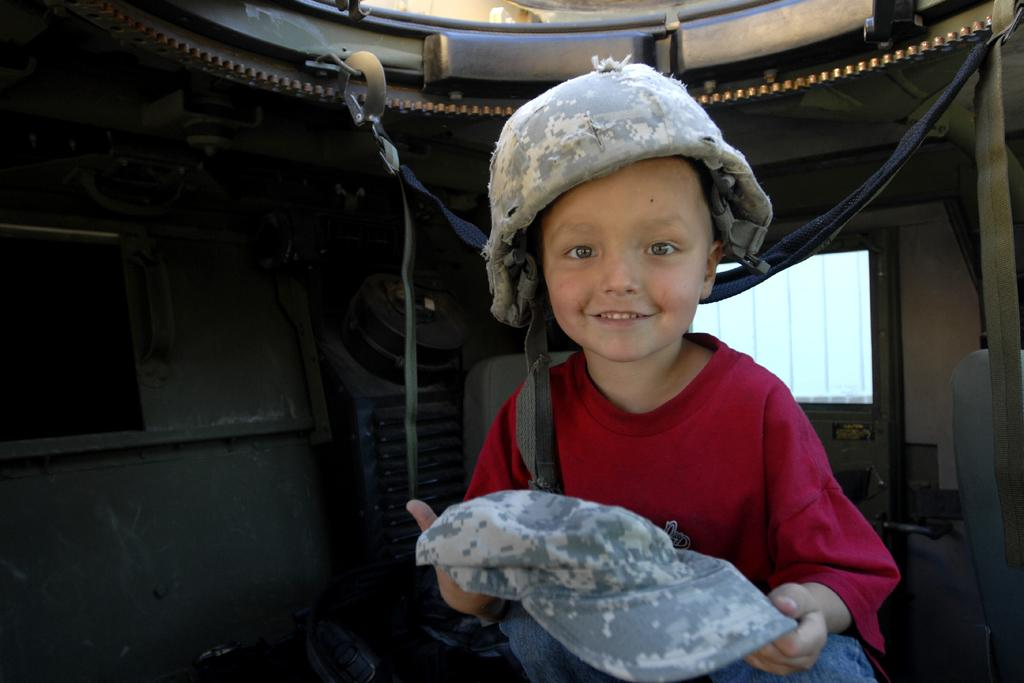What is the color of the background in the image? The background of the image is dark. What items can be seen in the image besides the boy? There are belts and objects in the image. What is the boy wearing in the image? The boy is wearing a t-shirt. What is the boy holding in the image? The boy is holding a cap. What is the boy's facial expression in the image? The boy is smiling in the image. How many snakes are slithering around the boy in the image? There are no snakes present in the image; the boy is surrounded by belts and objects. What time of day is it in the image, based on the hour? The provided facts do not mention the time of day or any specific hour, so it cannot be determined from the image. 